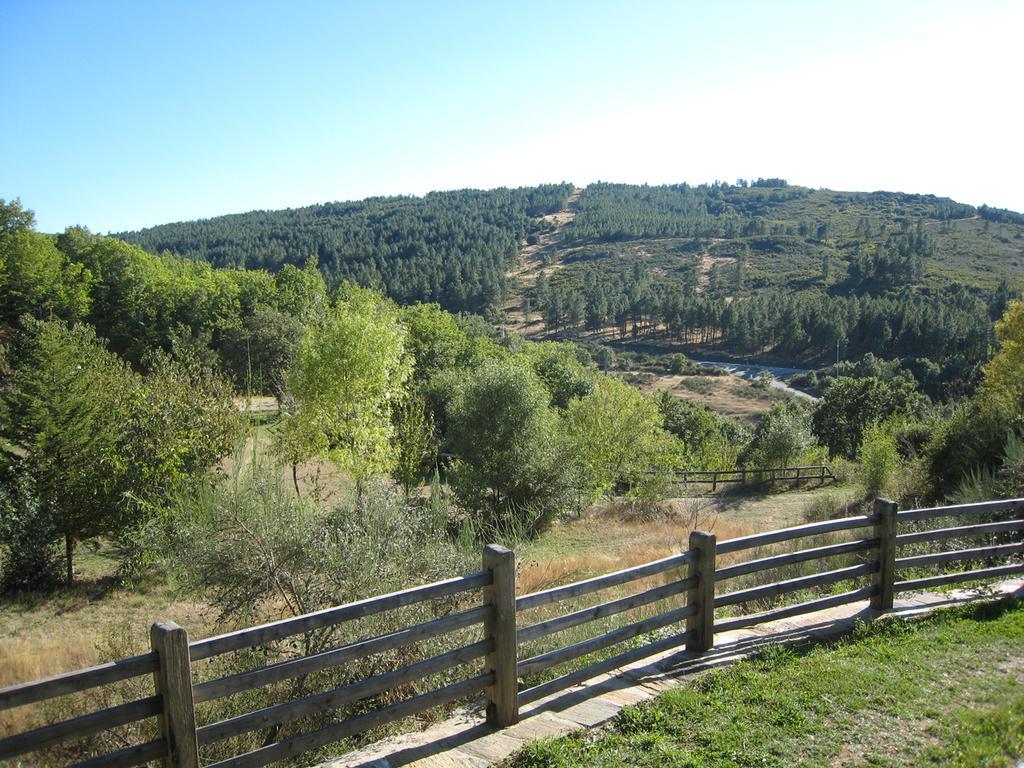Please provide a concise description of this image. In this picture I can observe railing in the bottom of the picture. In the background there are trees and sky. 